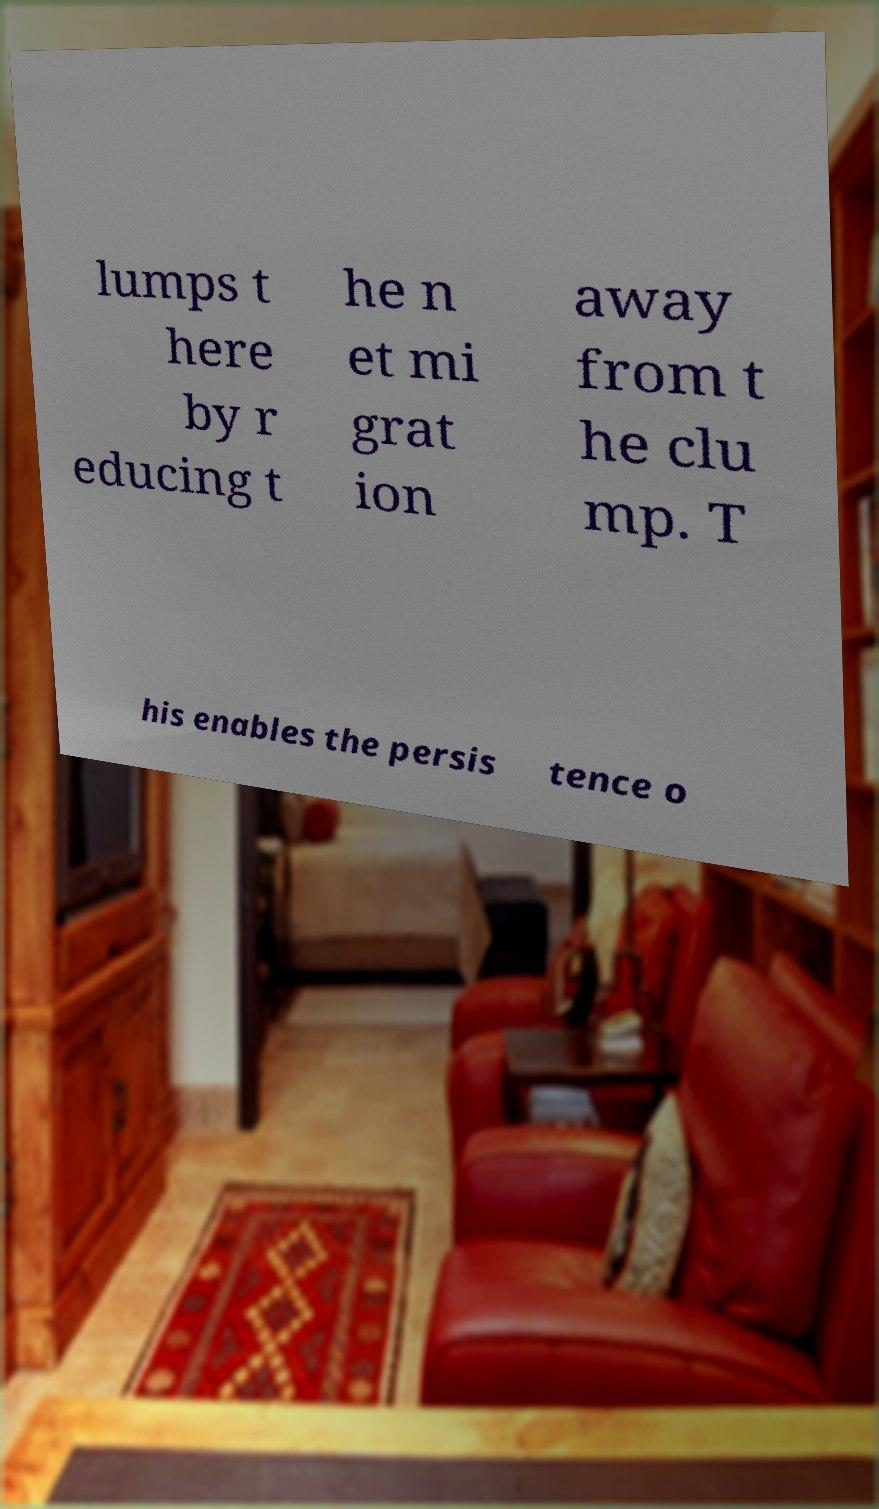What messages or text are displayed in this image? I need them in a readable, typed format. lumps t here by r educing t he n et mi grat ion away from t he clu mp. T his enables the persis tence o 